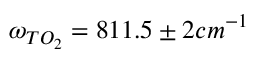Convert formula to latex. <formula><loc_0><loc_0><loc_500><loc_500>\omega _ { T O _ { 2 } } = 8 1 1 . 5 \pm 2 c m ^ { - 1 }</formula> 